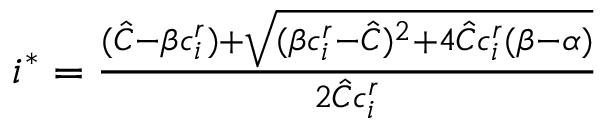<formula> <loc_0><loc_0><loc_500><loc_500>\begin{array} { r } { i ^ { * } = \frac { ( \hat { C } - \beta c _ { i } ^ { r } ) + \sqrt { ( \beta c _ { i } ^ { r } - \hat { C } ) ^ { 2 } + 4 \hat { C } c _ { i } ^ { r } ( \beta - \alpha ) } } { 2 \hat { C } c _ { i } ^ { r } } } \end{array}</formula> 